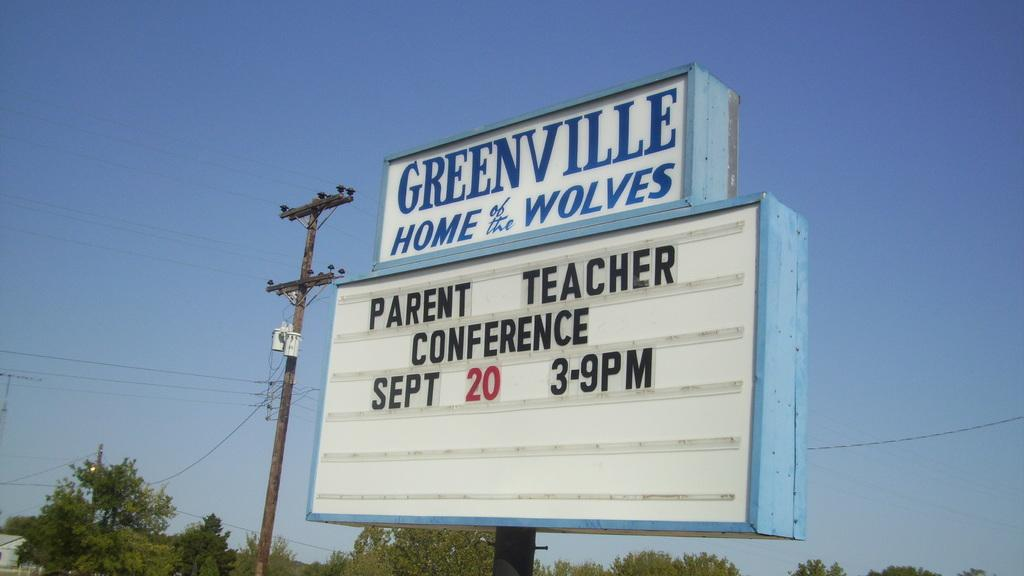Provide a one-sentence caption for the provided image. A Greenville school signboard advertising a parent and teacher conference. 